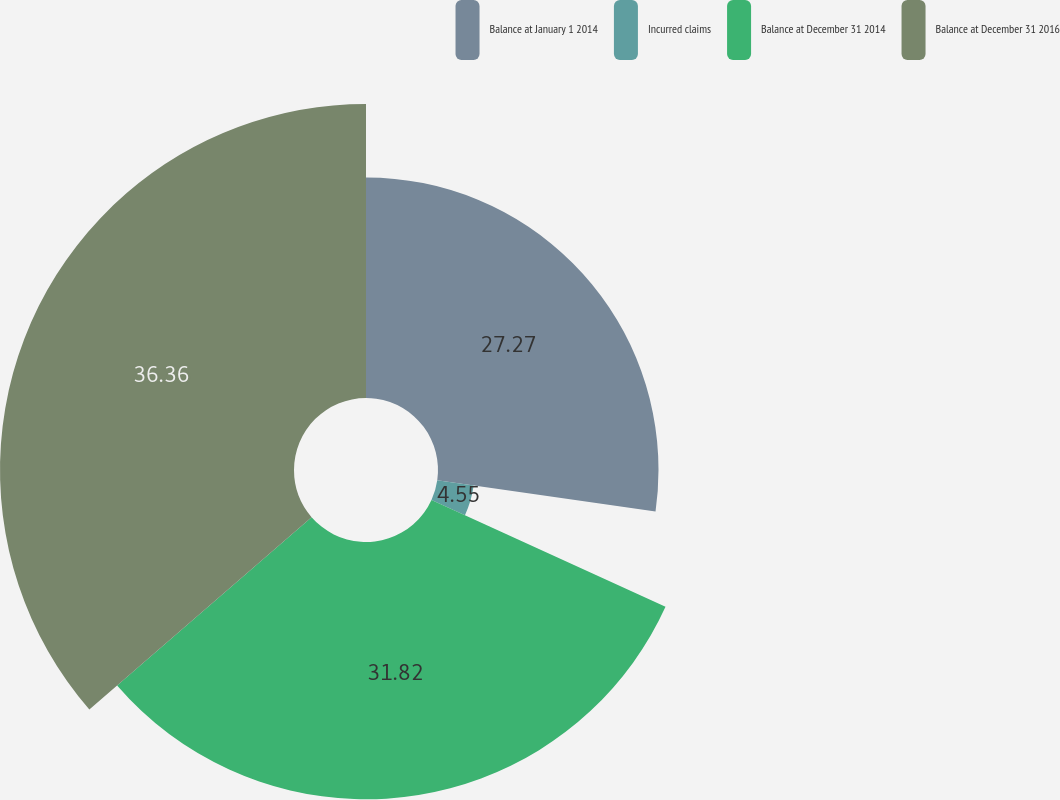Convert chart. <chart><loc_0><loc_0><loc_500><loc_500><pie_chart><fcel>Balance at January 1 2014<fcel>Incurred claims<fcel>Balance at December 31 2014<fcel>Balance at December 31 2016<nl><fcel>27.27%<fcel>4.55%<fcel>31.82%<fcel>36.36%<nl></chart> 